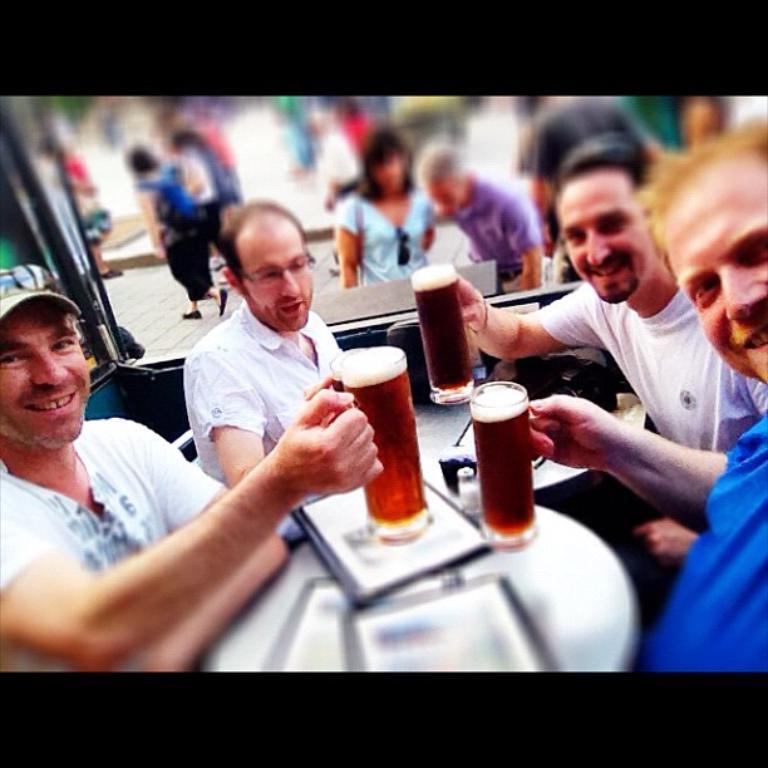Can you describe this image briefly? Group of people enjoying their beer ,these people are holding beer glasses in their hands ,a table is present behind them ,a person is wearing a cap and glasses and behind them people are walking one woman is standing she is carrying a bag she is in blue shirt ,one person is wearing glasses. 